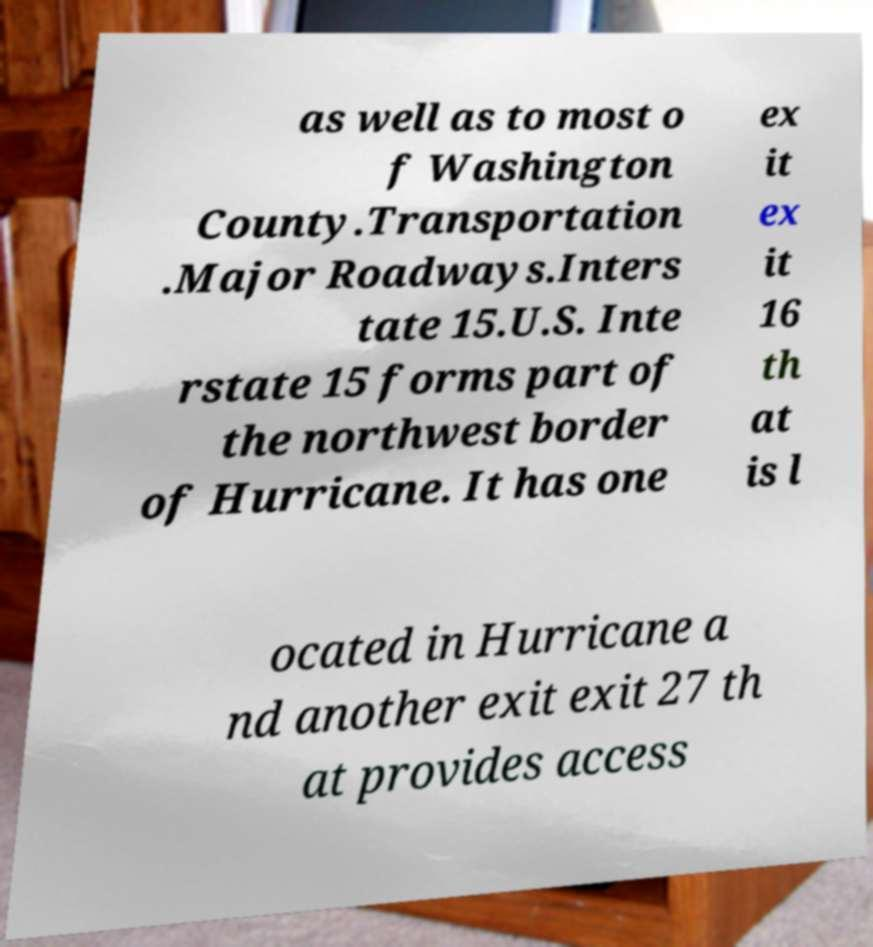What messages or text are displayed in this image? I need them in a readable, typed format. as well as to most o f Washington County.Transportation .Major Roadways.Inters tate 15.U.S. Inte rstate 15 forms part of the northwest border of Hurricane. It has one ex it ex it 16 th at is l ocated in Hurricane a nd another exit exit 27 th at provides access 